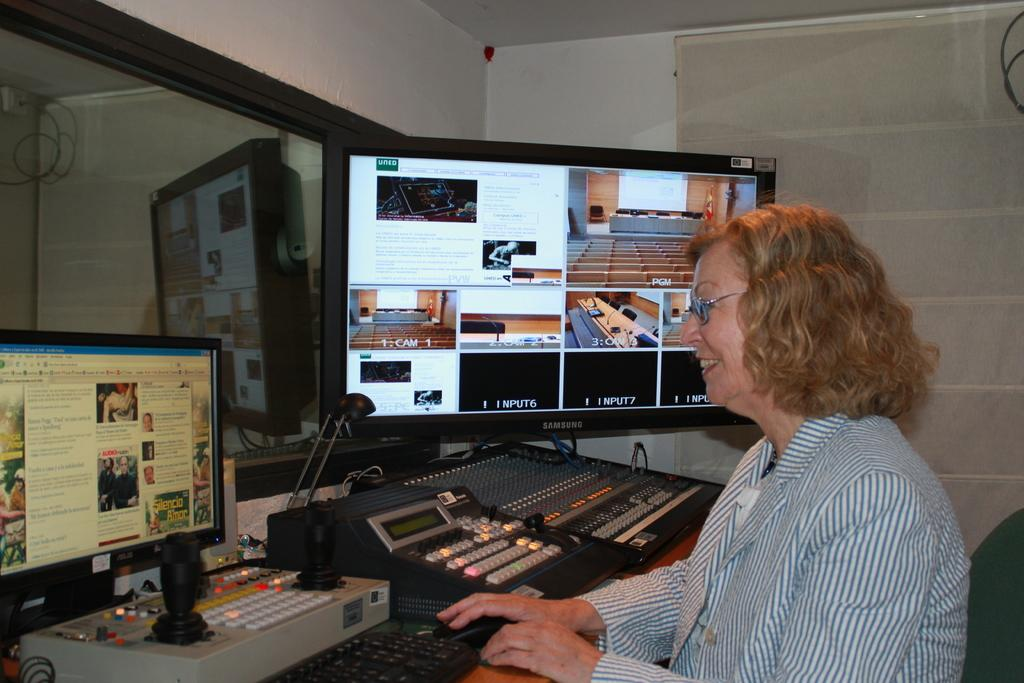Provide a one-sentence caption for the provided image. a lady is smiling at a small monitor with a large monitor beside her that is labeled with the cameras it is watching. 